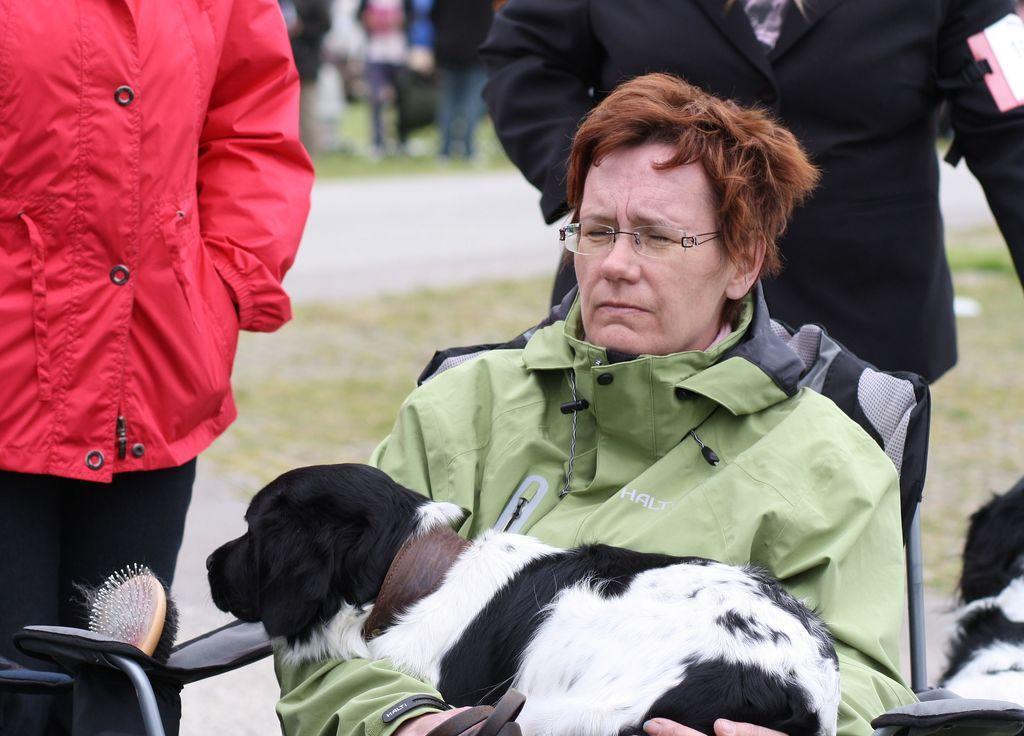Describe this image in one or two sentences. In this picture there is a woman sitting in a chair and holding a dog in her hands and there are few people standing behind her. 